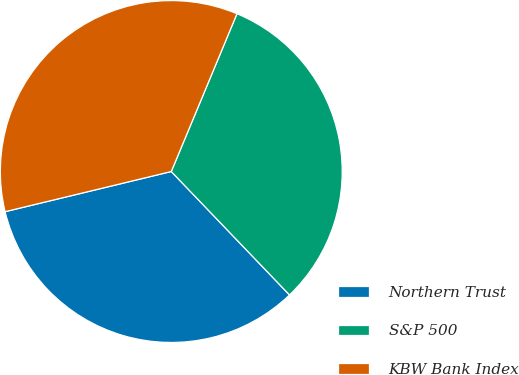<chart> <loc_0><loc_0><loc_500><loc_500><pie_chart><fcel>Northern Trust<fcel>S&P 500<fcel>KBW Bank Index<nl><fcel>33.38%<fcel>31.56%<fcel>35.05%<nl></chart> 